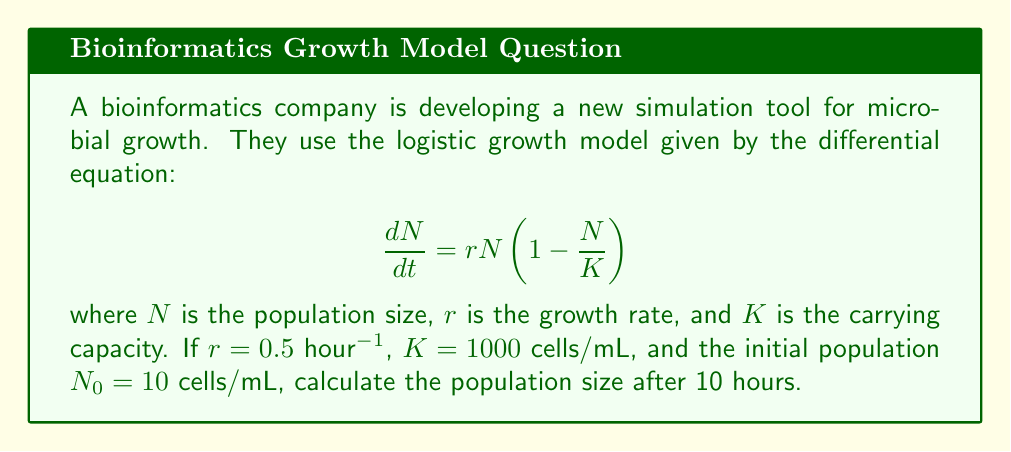What is the answer to this math problem? To solve this problem, we'll use the analytical solution of the logistic growth model:

1) The solution to the logistic growth equation is:

   $$N(t) = \frac{K}{1 + (\frac{K}{N_0} - 1)e^{-rt}}$$

2) We're given:
   $r = 0.5$ hour$^{-1}$
   $K = 1000$ cells/mL
   $N_0 = 10$ cells/mL
   $t = 10$ hours

3) Let's substitute these values into the equation:

   $$N(10) = \frac{1000}{1 + (\frac{1000}{10} - 1)e^{-0.5 \cdot 10}}$$

4) Simplify inside the parentheses:
   
   $$N(10) = \frac{1000}{1 + (99)e^{-5}}$$

5) Calculate $e^{-5}$:
   
   $$N(10) = \frac{1000}{1 + 99 \cdot 0.00674}$$

6) Multiply:
   
   $$N(10) = \frac{1000}{1 + 0.66726}$$

7) Add in the denominator:
   
   $$N(10) = \frac{1000}{1.66726}$$

8) Divide:
   
   $$N(10) \approx 599.79$$ cells/mL

9) Round to the nearest whole number as we're dealing with cells:
   
   $$N(10) \approx 600$$ cells/mL
Answer: 600 cells/mL 